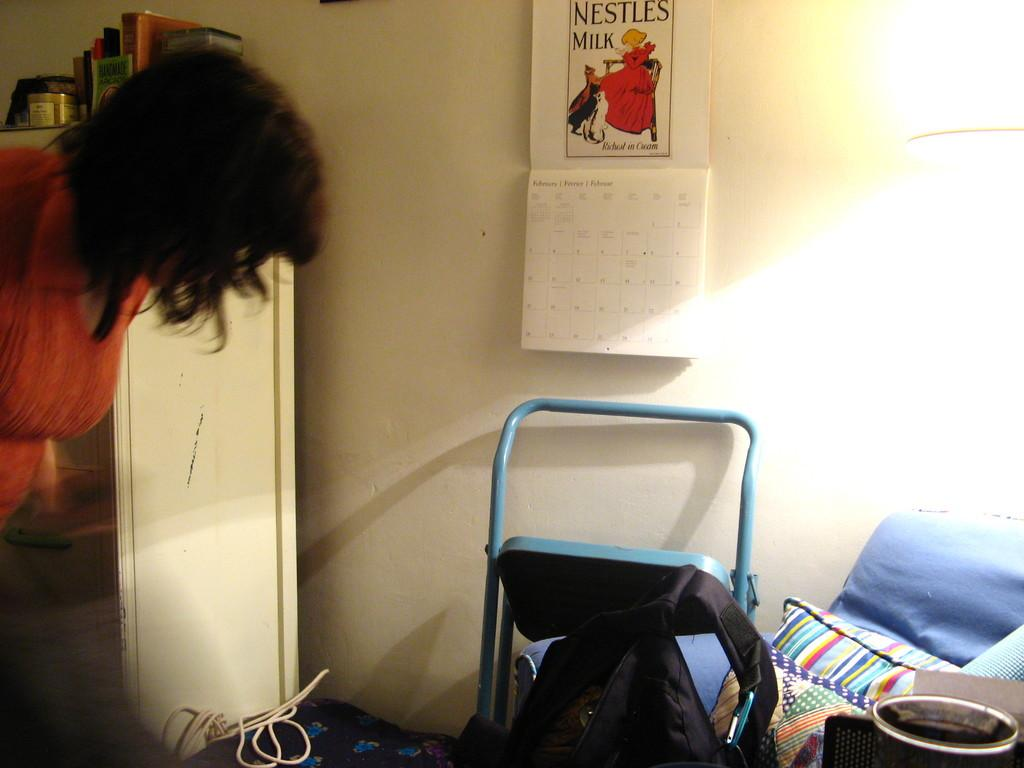What type of structure can be seen in the image? There is a wall in the image. What object is hanging on the wall? There is a calendar in the image. What piece of furniture is present in the image? There is a cupboard in the image. Can you describe the person in the image? There is a person in the image. What type of yam is the person holding in the image? There is no yam present in the image; the person is not holding any object. How fast is the person running in the image? There is no indication of the person running in the image; they are standing still. 